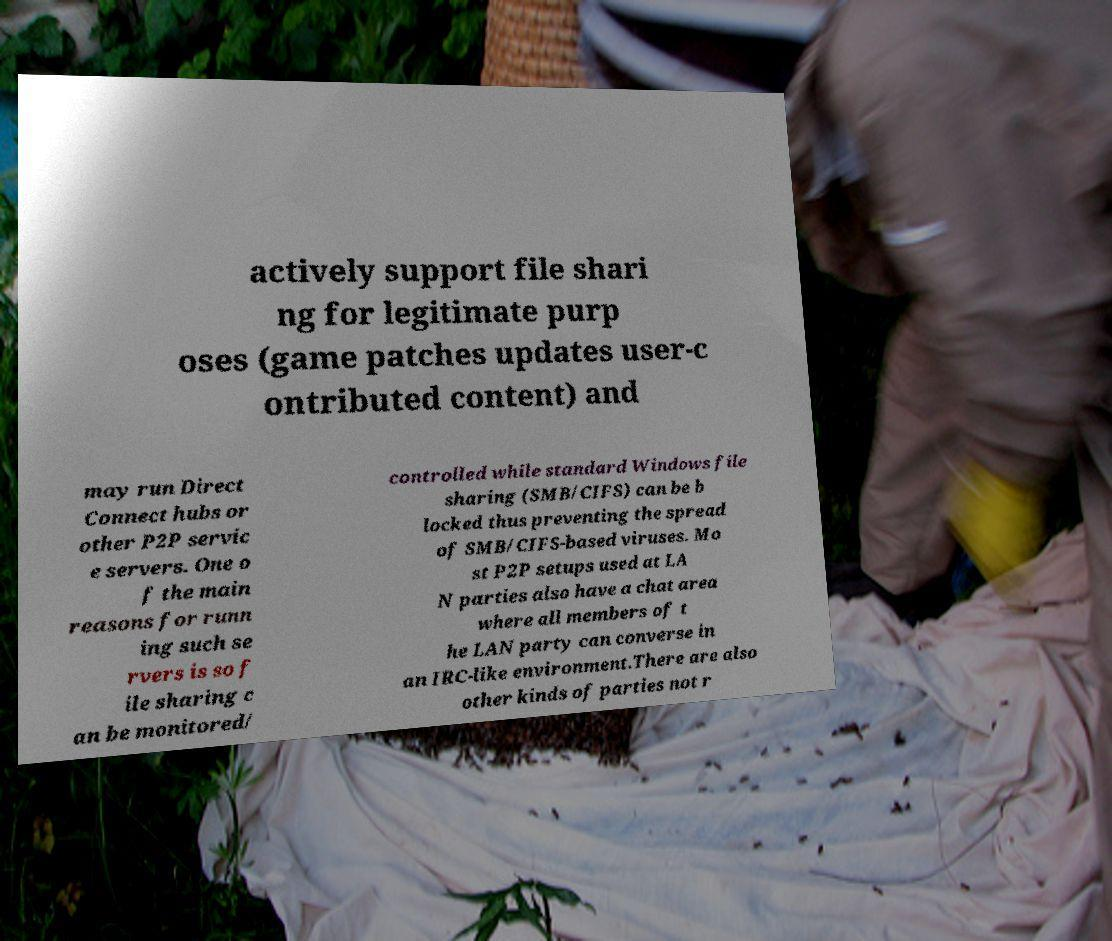What messages or text are displayed in this image? I need them in a readable, typed format. actively support file shari ng for legitimate purp oses (game patches updates user-c ontributed content) and may run Direct Connect hubs or other P2P servic e servers. One o f the main reasons for runn ing such se rvers is so f ile sharing c an be monitored/ controlled while standard Windows file sharing (SMB/CIFS) can be b locked thus preventing the spread of SMB/CIFS-based viruses. Mo st P2P setups used at LA N parties also have a chat area where all members of t he LAN party can converse in an IRC-like environment.There are also other kinds of parties not r 